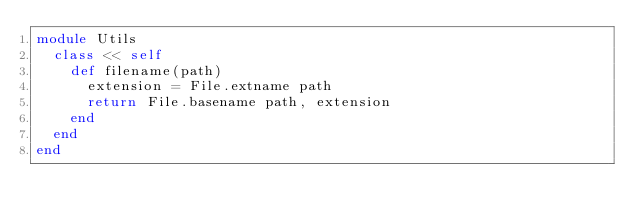Convert code to text. <code><loc_0><loc_0><loc_500><loc_500><_Ruby_>module Utils
  class << self
    def filename(path)
      extension = File.extname path
      return File.basename path, extension
    end 
  end
end</code> 